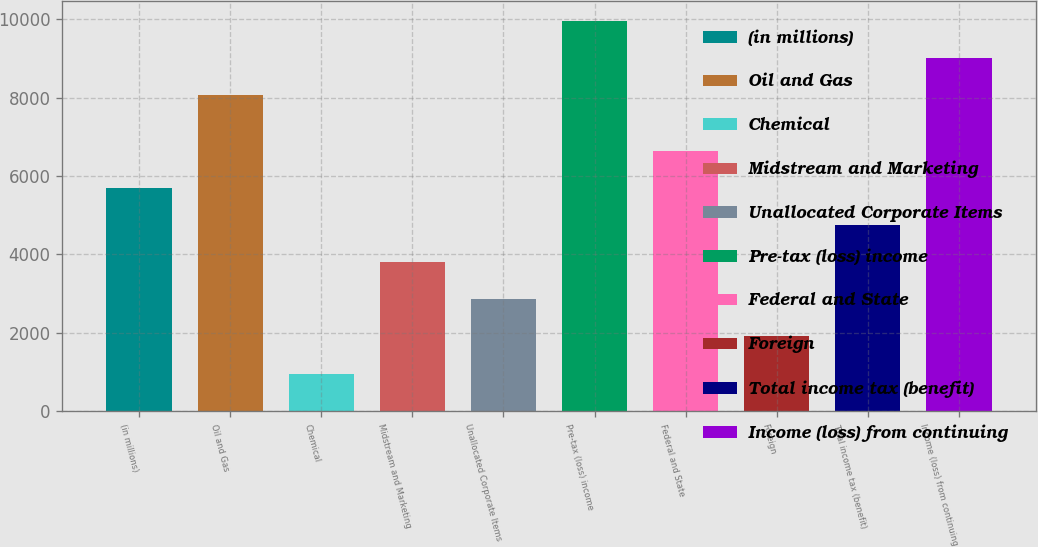Convert chart to OTSL. <chart><loc_0><loc_0><loc_500><loc_500><bar_chart><fcel>(in millions)<fcel>Oil and Gas<fcel>Chemical<fcel>Midstream and Marketing<fcel>Unallocated Corporate Items<fcel>Pre-tax (loss) income<fcel>Federal and State<fcel>Foreign<fcel>Total income tax (benefit)<fcel>Income (loss) from continuing<nl><fcel>5691.2<fcel>8060<fcel>960.2<fcel>3798.8<fcel>2852.6<fcel>9952.4<fcel>6637.4<fcel>1906.4<fcel>4745<fcel>9006.2<nl></chart> 